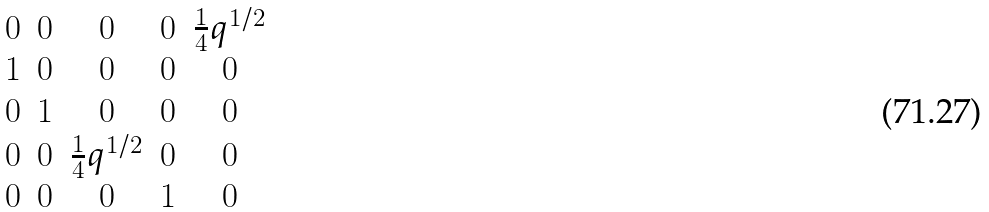<formula> <loc_0><loc_0><loc_500><loc_500>\begin{matrix} 0 & 0 & 0 & 0 & \frac { 1 } { 4 } q ^ { 1 / 2 } \\ 1 & 0 & 0 & 0 & 0 \\ 0 & 1 & 0 & 0 & 0 \\ 0 & 0 & \frac { 1 } { 4 } q ^ { 1 / 2 } & 0 & 0 \\ 0 & 0 & 0 & 1 & 0 \\ \end{matrix}</formula> 